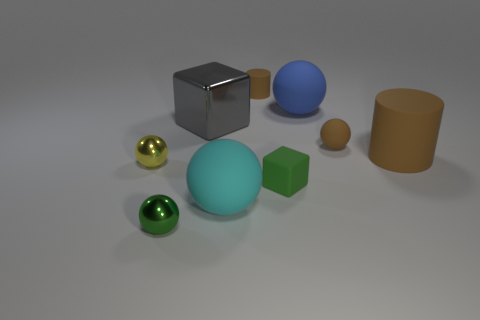There is a shiny thing that is in front of the big cyan object; is it the same size as the cylinder behind the big gray cube?
Keep it short and to the point. Yes. Are there more tiny green objects that are behind the big brown rubber cylinder than tiny green cubes left of the large cyan object?
Your answer should be compact. No. Are there any tiny green objects made of the same material as the small cylinder?
Your response must be concise. Yes. Does the tiny matte ball have the same color as the big metal thing?
Your answer should be compact. No. There is a thing that is behind the small cube and to the left of the gray metallic object; what material is it made of?
Ensure brevity in your answer.  Metal. What is the color of the small matte sphere?
Provide a succinct answer. Brown. What number of other large things have the same shape as the large blue rubber object?
Give a very brief answer. 1. Is the green object that is on the left side of the shiny block made of the same material as the green thing on the right side of the small brown rubber cylinder?
Give a very brief answer. No. There is a brown cylinder that is behind the large sphere behind the yellow metallic sphere; what size is it?
Offer a very short reply. Small. Is there anything else that is the same size as the brown matte ball?
Your answer should be compact. Yes. 